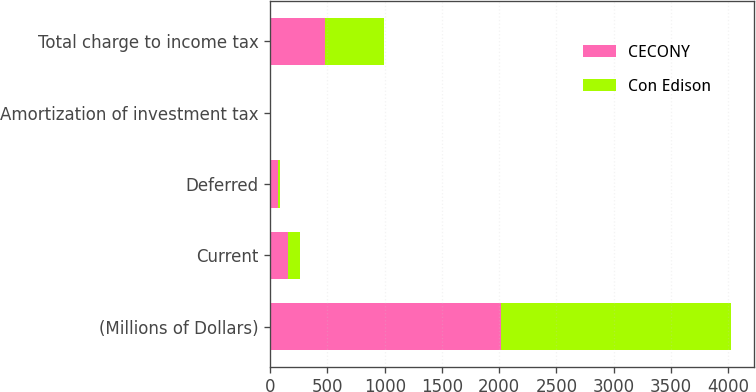Convert chart to OTSL. <chart><loc_0><loc_0><loc_500><loc_500><stacked_bar_chart><ecel><fcel>(Millions of Dollars)<fcel>Current<fcel>Deferred<fcel>Amortization of investment tax<fcel>Total charge to income tax<nl><fcel>CECONY<fcel>2013<fcel>151<fcel>70<fcel>5<fcel>476<nl><fcel>Con Edison<fcel>2013<fcel>111<fcel>14<fcel>5<fcel>520<nl></chart> 